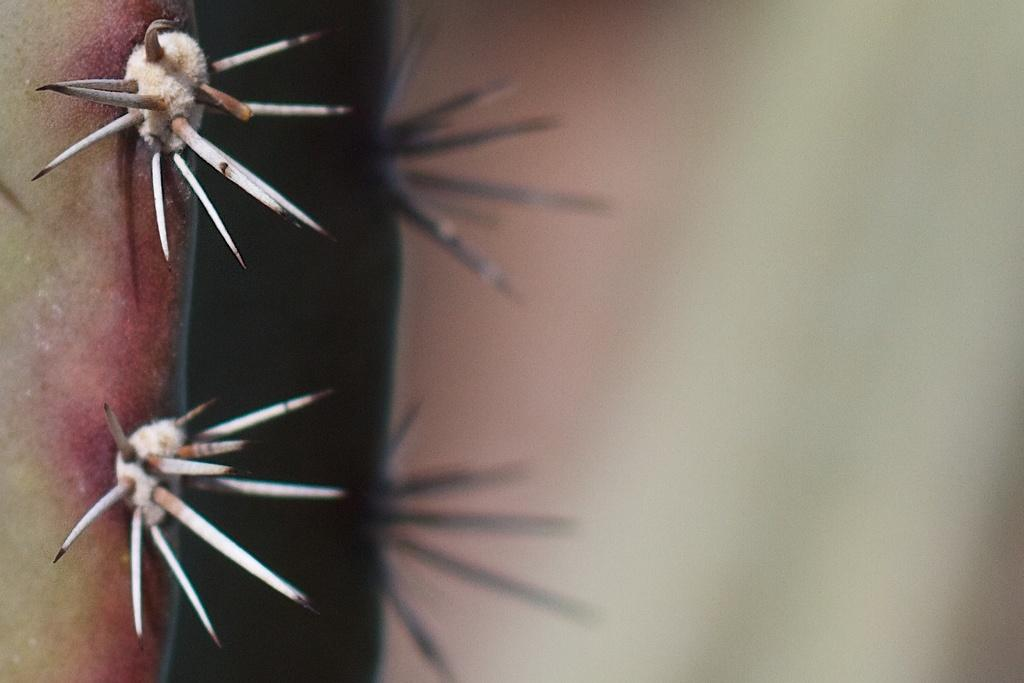What type of plants are in the image? There are dessert plants in the image. What feature do these plants have? The dessert plants are covered with thorns. What flavor of ice cream is being served on the train in the image? There is no train or ice cream present in the image; it features dessert plants covered with thorns. What type of animal can be seen interacting with the dessert plants in the image? There are no animals present in the image; it only features dessert plants covered with thorns. 